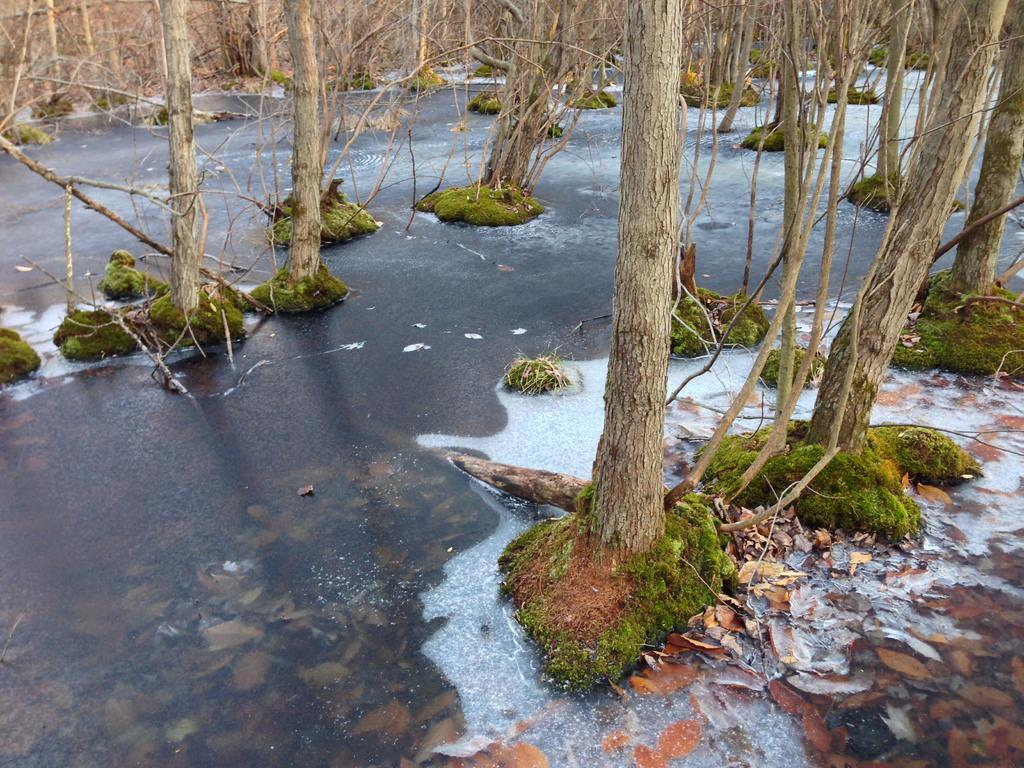What type of vegetation can be seen in the image? There are trees in the image. What is the condition of the leaves on the trees? Dried leaves are present in the image. What natural element is visible in the image? There is water visible in the image. What type of feast is being prepared in the image? There is no indication of a feast or any food preparation in the image. 